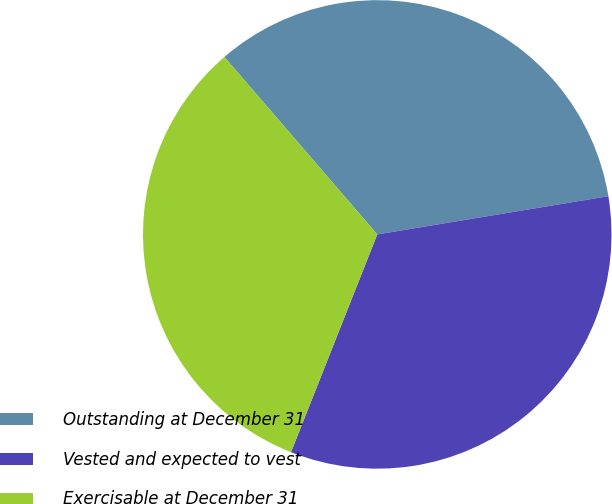Convert chart. <chart><loc_0><loc_0><loc_500><loc_500><pie_chart><fcel>Outstanding at December 31<fcel>Vested and expected to vest<fcel>Exercisable at December 31<nl><fcel>33.71%<fcel>33.61%<fcel>32.68%<nl></chart> 